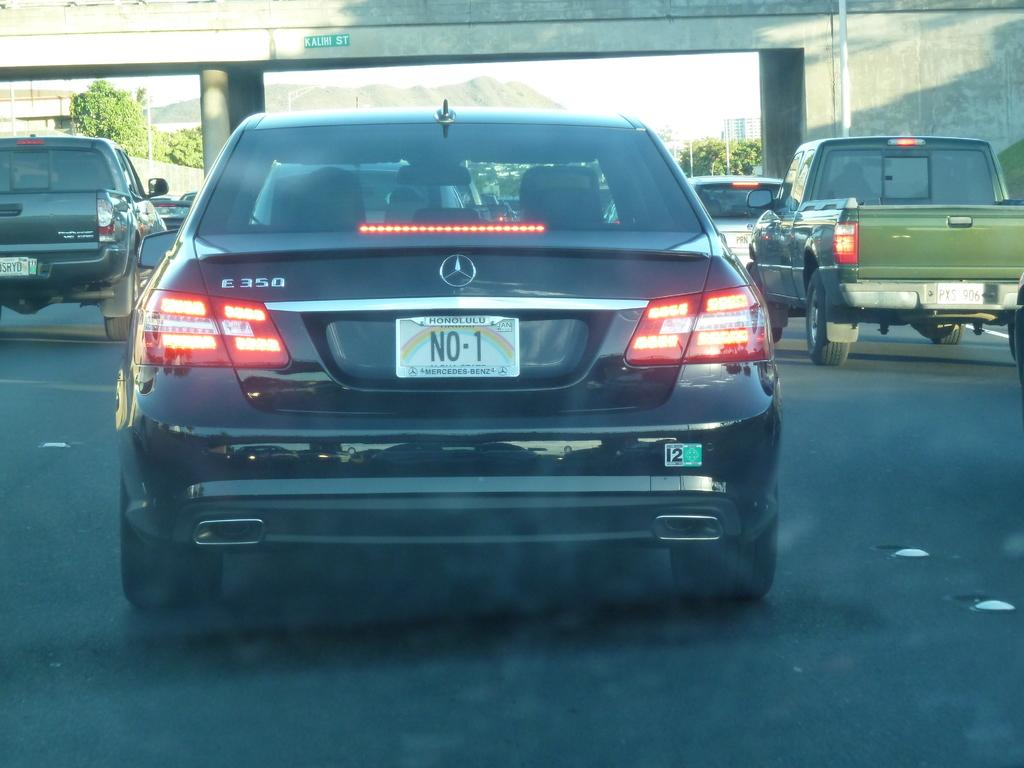What can be seen on the road in the image? There are vehicles on the road in the image. What is visible in the background of the image? In the background of the image, there is a bridge, poles, trees, buildings, a mountain, and the sky. How many creatures are riding the bikes in the image? There are no bikes present in the image, and therefore no creatures riding them. Where is the pocket located in the image? There is no pocket present in the image. 